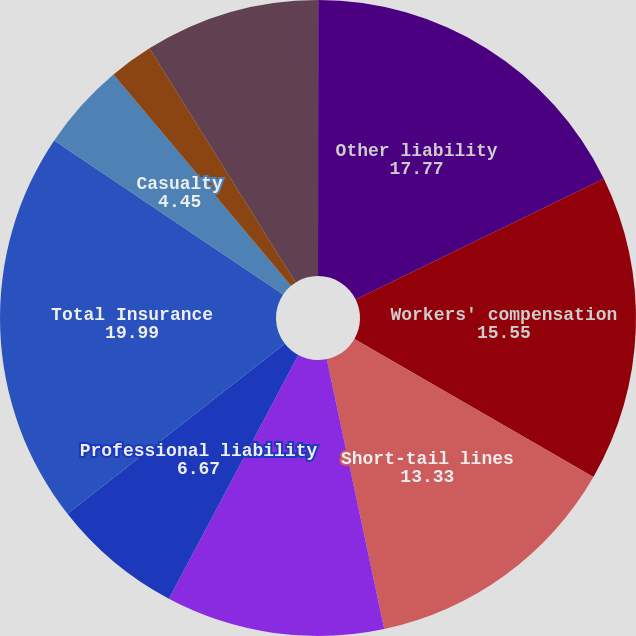Convert chart to OTSL. <chart><loc_0><loc_0><loc_500><loc_500><pie_chart><fcel>(In thousands)<fcel>Other liability<fcel>Workers' compensation<fcel>Short-tail lines<fcel>Commercial automobile<fcel>Professional liability<fcel>Total Insurance<fcel>Casualty<fcel>Property<fcel>Total Reinsurance<nl><fcel>0.01%<fcel>17.77%<fcel>15.55%<fcel>13.33%<fcel>11.11%<fcel>6.67%<fcel>19.99%<fcel>4.45%<fcel>2.23%<fcel>8.89%<nl></chart> 